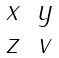<formula> <loc_0><loc_0><loc_500><loc_500>\| \begin{matrix} x & y \\ z & v \end{matrix} \|</formula> 